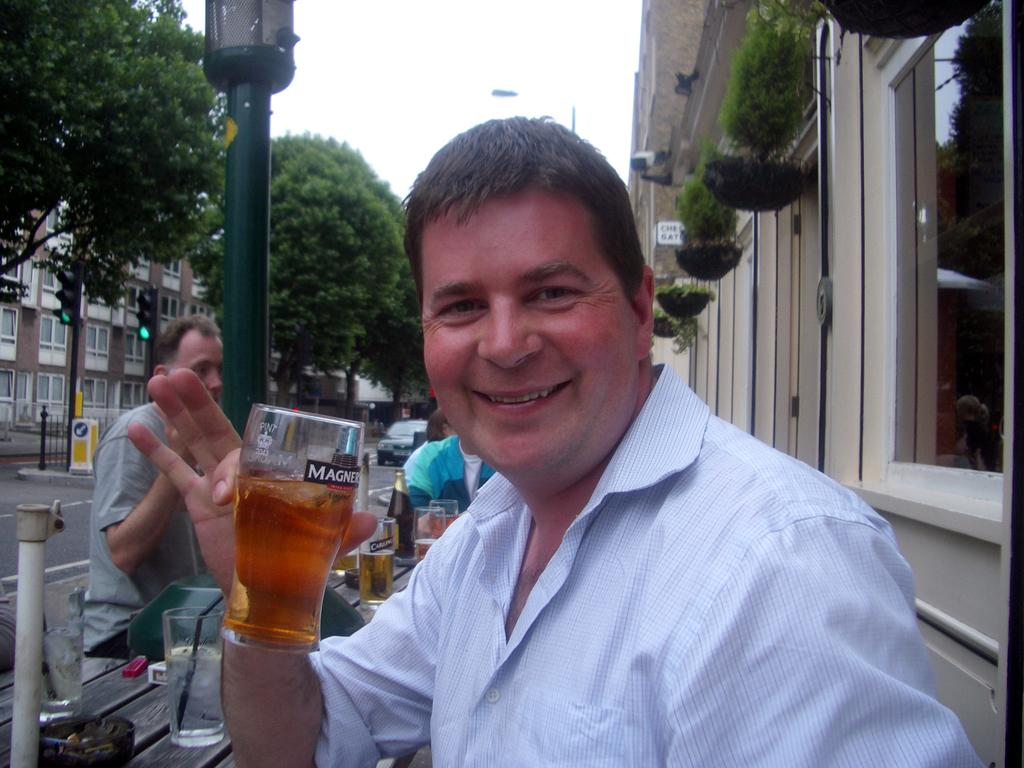Who is present in the image? There is a man in the image. What is the man holding in the image? The man is holding a beer glass. Where was the image likely taken? The image appears to be taken on a street. What can be seen on the right side of the image? There is a building on the right side of the image. What type of vegetation is on the left side of the image? There are trees on the left side of the image. How does the man tie a knot with the beer glass in the image? There is no knot-tying activity involving the beer glass in the image. What causes the man to cough in the image? There is no coughing depicted in the image. 